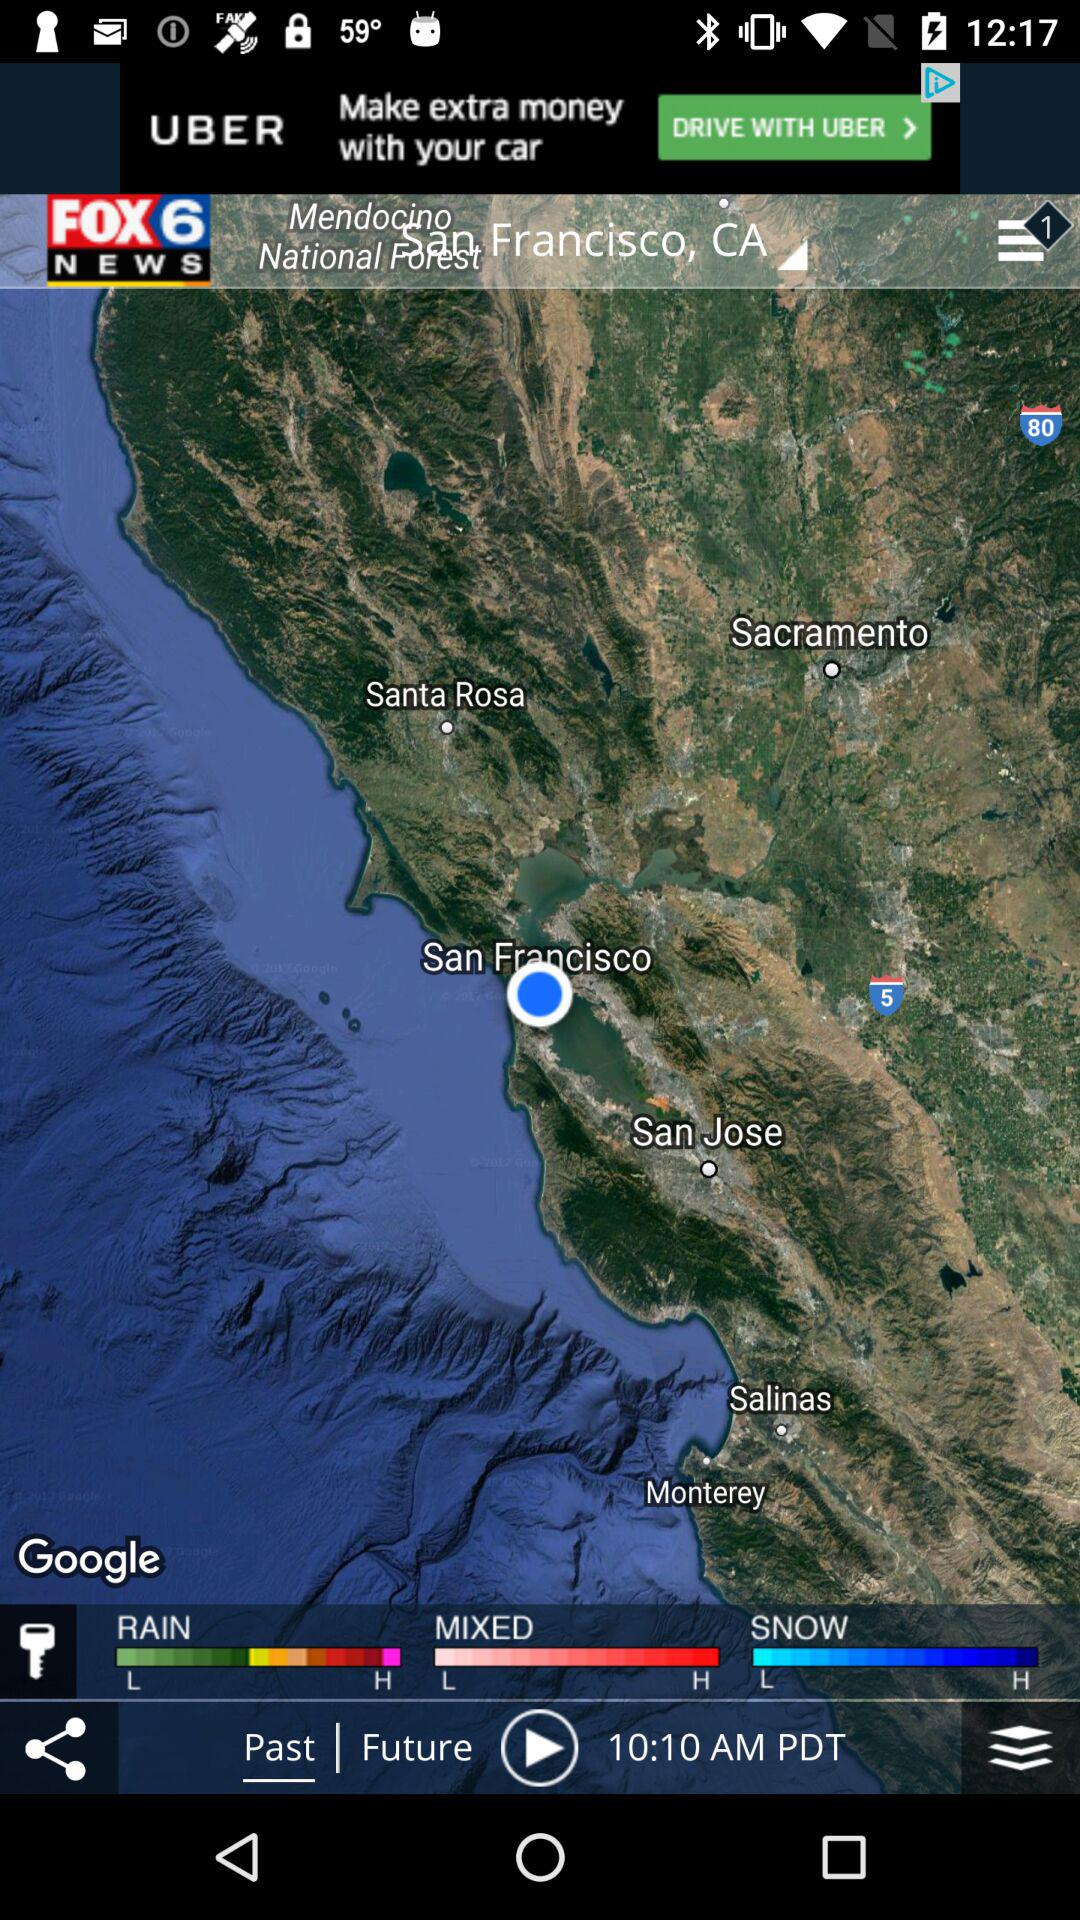How many different weather conditions are available?
Answer the question using a single word or phrase. 3 